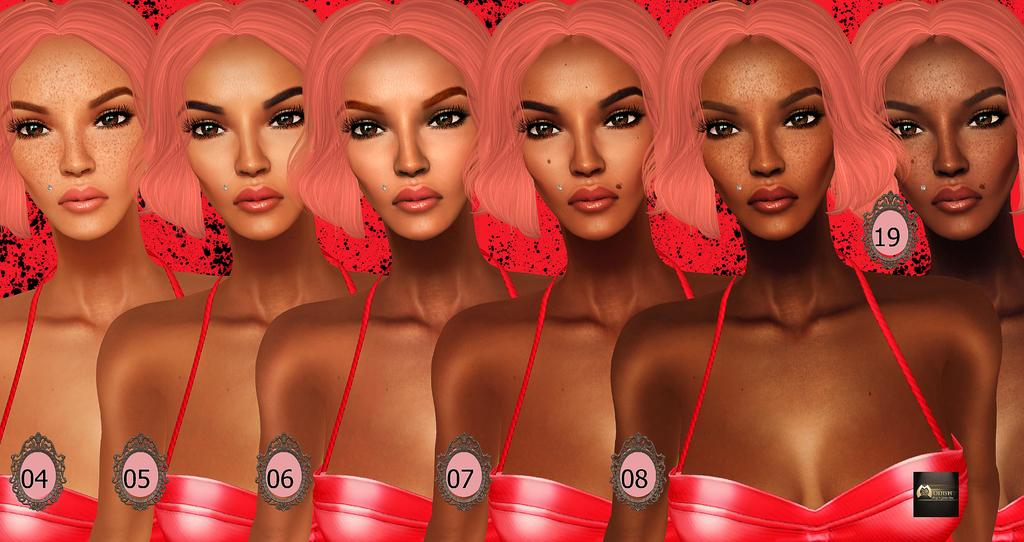What type of image is being described? The image is an animated picture. What type of characters are present in the image? There are women in the image. How are the women positioned in the image? The women are standing in a sequence. What additional information is associated with the women in the sequence? Numeric numbers are associated with the women in the sequence. Where is the coach located in the image? There is no coach present in the image. What type of animals can be seen on the farm in the image? There is no farm present in the image. How does the brain function in the image? There is no brain present in the image. 